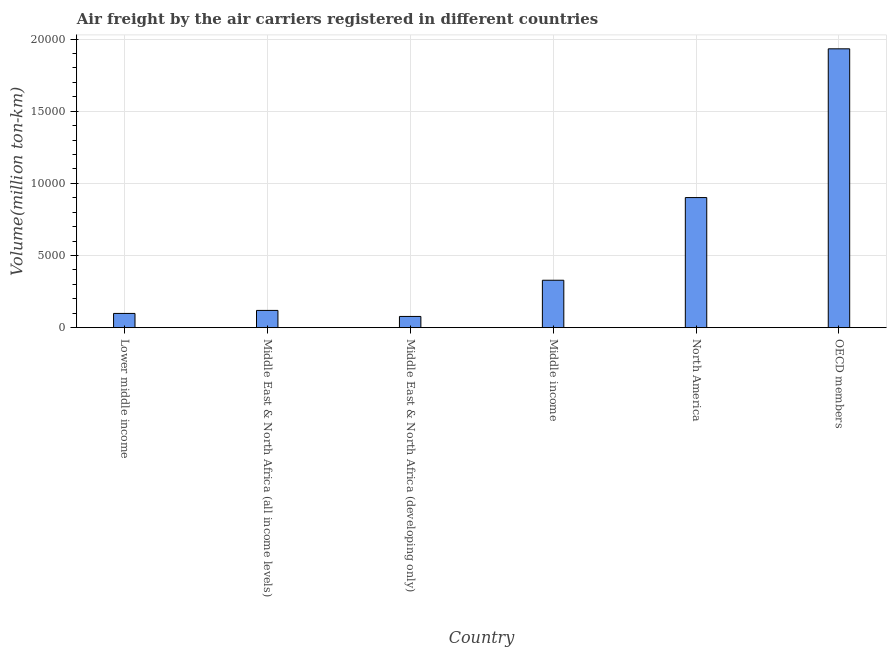Does the graph contain grids?
Offer a very short reply. Yes. What is the title of the graph?
Provide a short and direct response. Air freight by the air carriers registered in different countries. What is the label or title of the Y-axis?
Your answer should be compact. Volume(million ton-km). What is the air freight in North America?
Ensure brevity in your answer.  9015.4. Across all countries, what is the maximum air freight?
Your answer should be compact. 1.93e+04. Across all countries, what is the minimum air freight?
Keep it short and to the point. 777.3. In which country was the air freight maximum?
Offer a very short reply. OECD members. In which country was the air freight minimum?
Ensure brevity in your answer.  Middle East & North Africa (developing only). What is the sum of the air freight?
Your answer should be very brief. 3.46e+04. What is the difference between the air freight in Middle income and OECD members?
Keep it short and to the point. -1.60e+04. What is the average air freight per country?
Offer a terse response. 5764.37. What is the median air freight?
Provide a succinct answer. 2240.95. In how many countries, is the air freight greater than 10000 million ton-km?
Keep it short and to the point. 1. What is the ratio of the air freight in Lower middle income to that in Middle East & North Africa (developing only)?
Give a very brief answer. 1.27. Is the air freight in Middle East & North Africa (developing only) less than that in North America?
Provide a short and direct response. Yes. What is the difference between the highest and the second highest air freight?
Keep it short and to the point. 1.03e+04. Is the sum of the air freight in North America and OECD members greater than the maximum air freight across all countries?
Offer a terse response. Yes. What is the difference between the highest and the lowest air freight?
Offer a terse response. 1.85e+04. How many countries are there in the graph?
Provide a succinct answer. 6. What is the Volume(million ton-km) of Lower middle income?
Provide a short and direct response. 986.6. What is the Volume(million ton-km) of Middle East & North Africa (all income levels)?
Your response must be concise. 1195.5. What is the Volume(million ton-km) in Middle East & North Africa (developing only)?
Give a very brief answer. 777.3. What is the Volume(million ton-km) in Middle income?
Offer a very short reply. 3286.4. What is the Volume(million ton-km) of North America?
Make the answer very short. 9015.4. What is the Volume(million ton-km) in OECD members?
Offer a terse response. 1.93e+04. What is the difference between the Volume(million ton-km) in Lower middle income and Middle East & North Africa (all income levels)?
Keep it short and to the point. -208.9. What is the difference between the Volume(million ton-km) in Lower middle income and Middle East & North Africa (developing only)?
Make the answer very short. 209.3. What is the difference between the Volume(million ton-km) in Lower middle income and Middle income?
Your answer should be compact. -2299.8. What is the difference between the Volume(million ton-km) in Lower middle income and North America?
Provide a succinct answer. -8028.8. What is the difference between the Volume(million ton-km) in Lower middle income and OECD members?
Your answer should be compact. -1.83e+04. What is the difference between the Volume(million ton-km) in Middle East & North Africa (all income levels) and Middle East & North Africa (developing only)?
Ensure brevity in your answer.  418.2. What is the difference between the Volume(million ton-km) in Middle East & North Africa (all income levels) and Middle income?
Offer a terse response. -2090.9. What is the difference between the Volume(million ton-km) in Middle East & North Africa (all income levels) and North America?
Offer a very short reply. -7819.9. What is the difference between the Volume(million ton-km) in Middle East & North Africa (all income levels) and OECD members?
Offer a terse response. -1.81e+04. What is the difference between the Volume(million ton-km) in Middle East & North Africa (developing only) and Middle income?
Offer a very short reply. -2509.1. What is the difference between the Volume(million ton-km) in Middle East & North Africa (developing only) and North America?
Offer a terse response. -8238.1. What is the difference between the Volume(million ton-km) in Middle East & North Africa (developing only) and OECD members?
Your answer should be very brief. -1.85e+04. What is the difference between the Volume(million ton-km) in Middle income and North America?
Make the answer very short. -5729. What is the difference between the Volume(million ton-km) in Middle income and OECD members?
Provide a succinct answer. -1.60e+04. What is the difference between the Volume(million ton-km) in North America and OECD members?
Provide a succinct answer. -1.03e+04. What is the ratio of the Volume(million ton-km) in Lower middle income to that in Middle East & North Africa (all income levels)?
Provide a succinct answer. 0.82. What is the ratio of the Volume(million ton-km) in Lower middle income to that in Middle East & North Africa (developing only)?
Your answer should be compact. 1.27. What is the ratio of the Volume(million ton-km) in Lower middle income to that in North America?
Make the answer very short. 0.11. What is the ratio of the Volume(million ton-km) in Lower middle income to that in OECD members?
Provide a short and direct response. 0.05. What is the ratio of the Volume(million ton-km) in Middle East & North Africa (all income levels) to that in Middle East & North Africa (developing only)?
Ensure brevity in your answer.  1.54. What is the ratio of the Volume(million ton-km) in Middle East & North Africa (all income levels) to that in Middle income?
Offer a very short reply. 0.36. What is the ratio of the Volume(million ton-km) in Middle East & North Africa (all income levels) to that in North America?
Offer a very short reply. 0.13. What is the ratio of the Volume(million ton-km) in Middle East & North Africa (all income levels) to that in OECD members?
Keep it short and to the point. 0.06. What is the ratio of the Volume(million ton-km) in Middle East & North Africa (developing only) to that in Middle income?
Provide a short and direct response. 0.24. What is the ratio of the Volume(million ton-km) in Middle East & North Africa (developing only) to that in North America?
Provide a short and direct response. 0.09. What is the ratio of the Volume(million ton-km) in Middle income to that in North America?
Make the answer very short. 0.36. What is the ratio of the Volume(million ton-km) in Middle income to that in OECD members?
Your response must be concise. 0.17. What is the ratio of the Volume(million ton-km) in North America to that in OECD members?
Give a very brief answer. 0.47. 